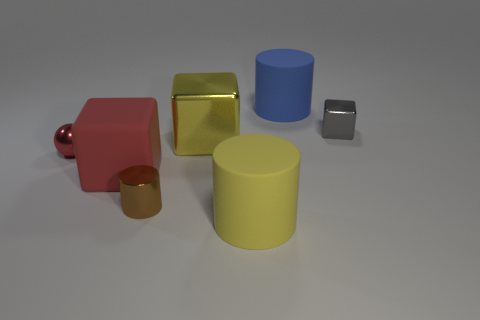Are there more red blocks than cubes?
Provide a succinct answer. No. Are there any other things that are the same color as the sphere?
Your response must be concise. Yes. How many other objects are the same size as the yellow matte object?
Your response must be concise. 3. What is the material of the tiny object that is right of the matte object behind the metallic thing that is on the left side of the large red thing?
Provide a short and direct response. Metal. Are the tiny red thing and the thing that is in front of the tiny brown thing made of the same material?
Give a very brief answer. No. Is the number of big matte blocks behind the yellow shiny cube less than the number of things right of the red sphere?
Your answer should be compact. Yes. How many brown objects are made of the same material as the gray object?
Keep it short and to the point. 1. There is a tiny object on the left side of the large block in front of the tiny ball; is there a matte thing that is behind it?
Keep it short and to the point. Yes. What number of balls are tiny yellow things or red metal objects?
Give a very brief answer. 1. There is a large blue matte object; is it the same shape as the big yellow object that is behind the big matte cube?
Offer a terse response. No. 